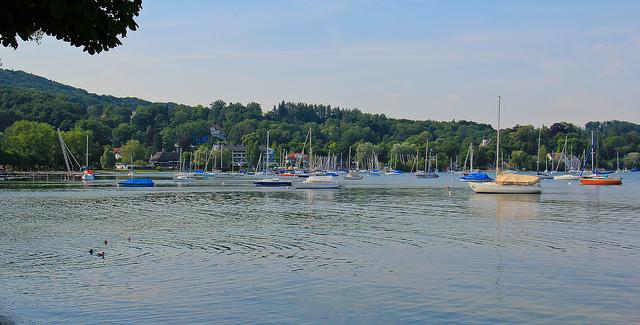Is it daytime?
Be succinct. Yes. What marina are the boats at?
Be succinct. Boat marina. How many rowboats are visible?
Write a very short answer. 0. What is the blue thing in the middle?
Concise answer only. Boat. How many birds are flying?
Quick response, please. 0. How many boats are there?
Give a very brief answer. 20. 